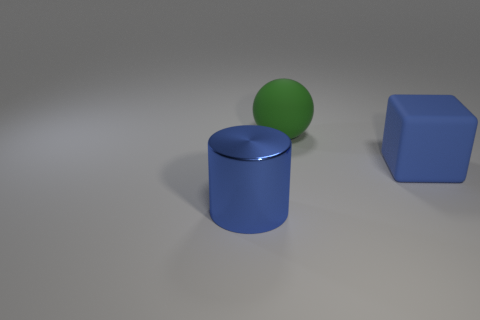There is a object that is in front of the big blue rubber thing; is its color the same as the block?
Keep it short and to the point. Yes. The thing that is behind the blue object that is to the right of the cylinder is what color?
Give a very brief answer. Green. What is the material of the big cube that is the same color as the large metal cylinder?
Offer a terse response. Rubber. There is a rubber thing behind the block; what is its color?
Make the answer very short. Green. There is a thing in front of the blue matte cube; does it have the same size as the green rubber thing?
Offer a terse response. Yes. There is a cylinder that is the same color as the cube; what size is it?
Offer a terse response. Large. Are there any blue matte cubes of the same size as the rubber ball?
Your response must be concise. Yes. Do the thing in front of the block and the big matte object that is on the right side of the big green object have the same color?
Keep it short and to the point. Yes. Are there any rubber cubes of the same color as the big metal thing?
Provide a succinct answer. Yes. How many other objects are there of the same shape as the large green rubber thing?
Ensure brevity in your answer.  0. 